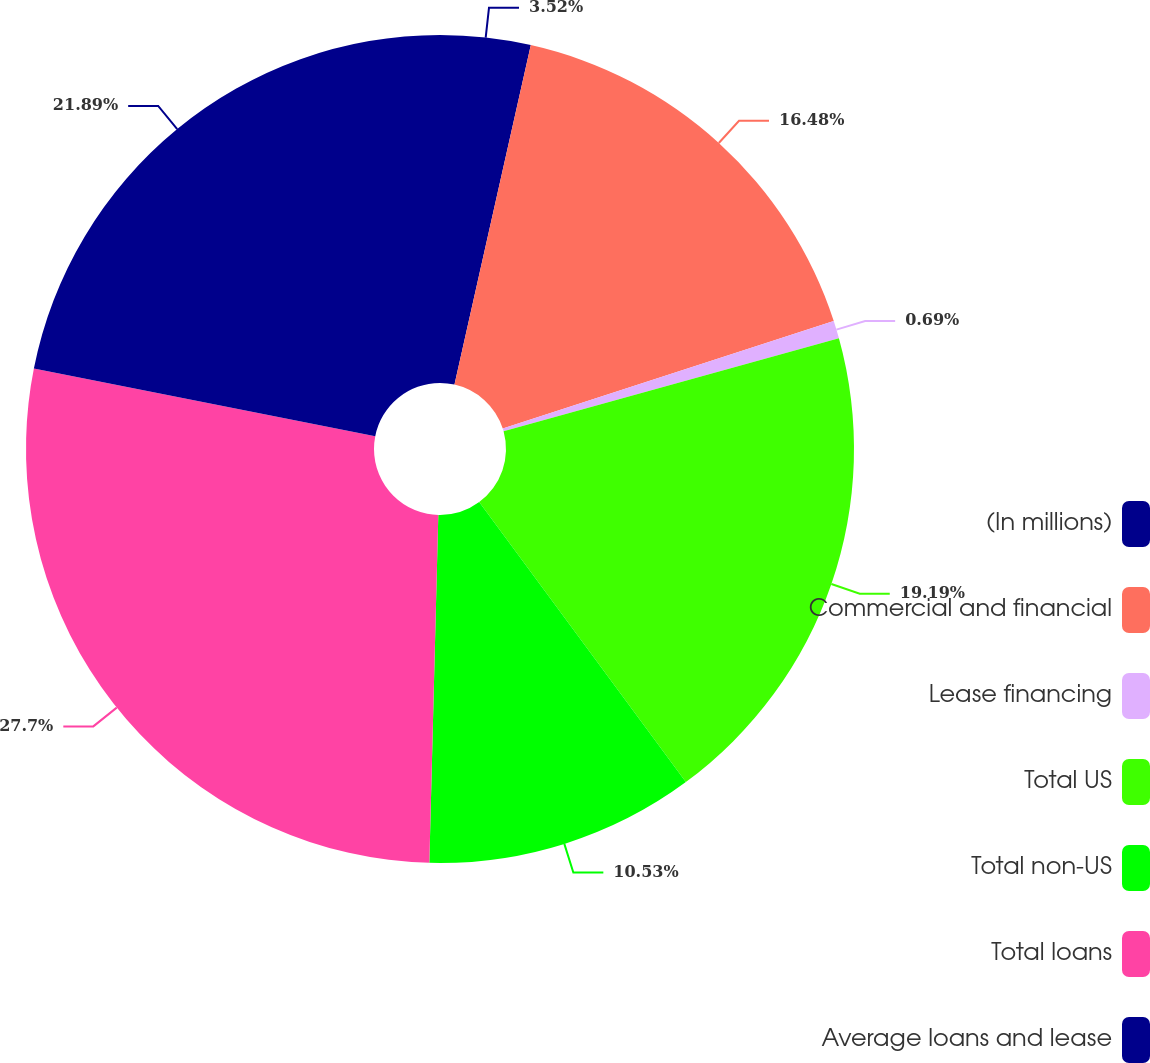Convert chart. <chart><loc_0><loc_0><loc_500><loc_500><pie_chart><fcel>(In millions)<fcel>Commercial and financial<fcel>Lease financing<fcel>Total US<fcel>Total non-US<fcel>Total loans<fcel>Average loans and lease<nl><fcel>3.52%<fcel>16.48%<fcel>0.69%<fcel>19.19%<fcel>10.53%<fcel>27.7%<fcel>21.89%<nl></chart> 